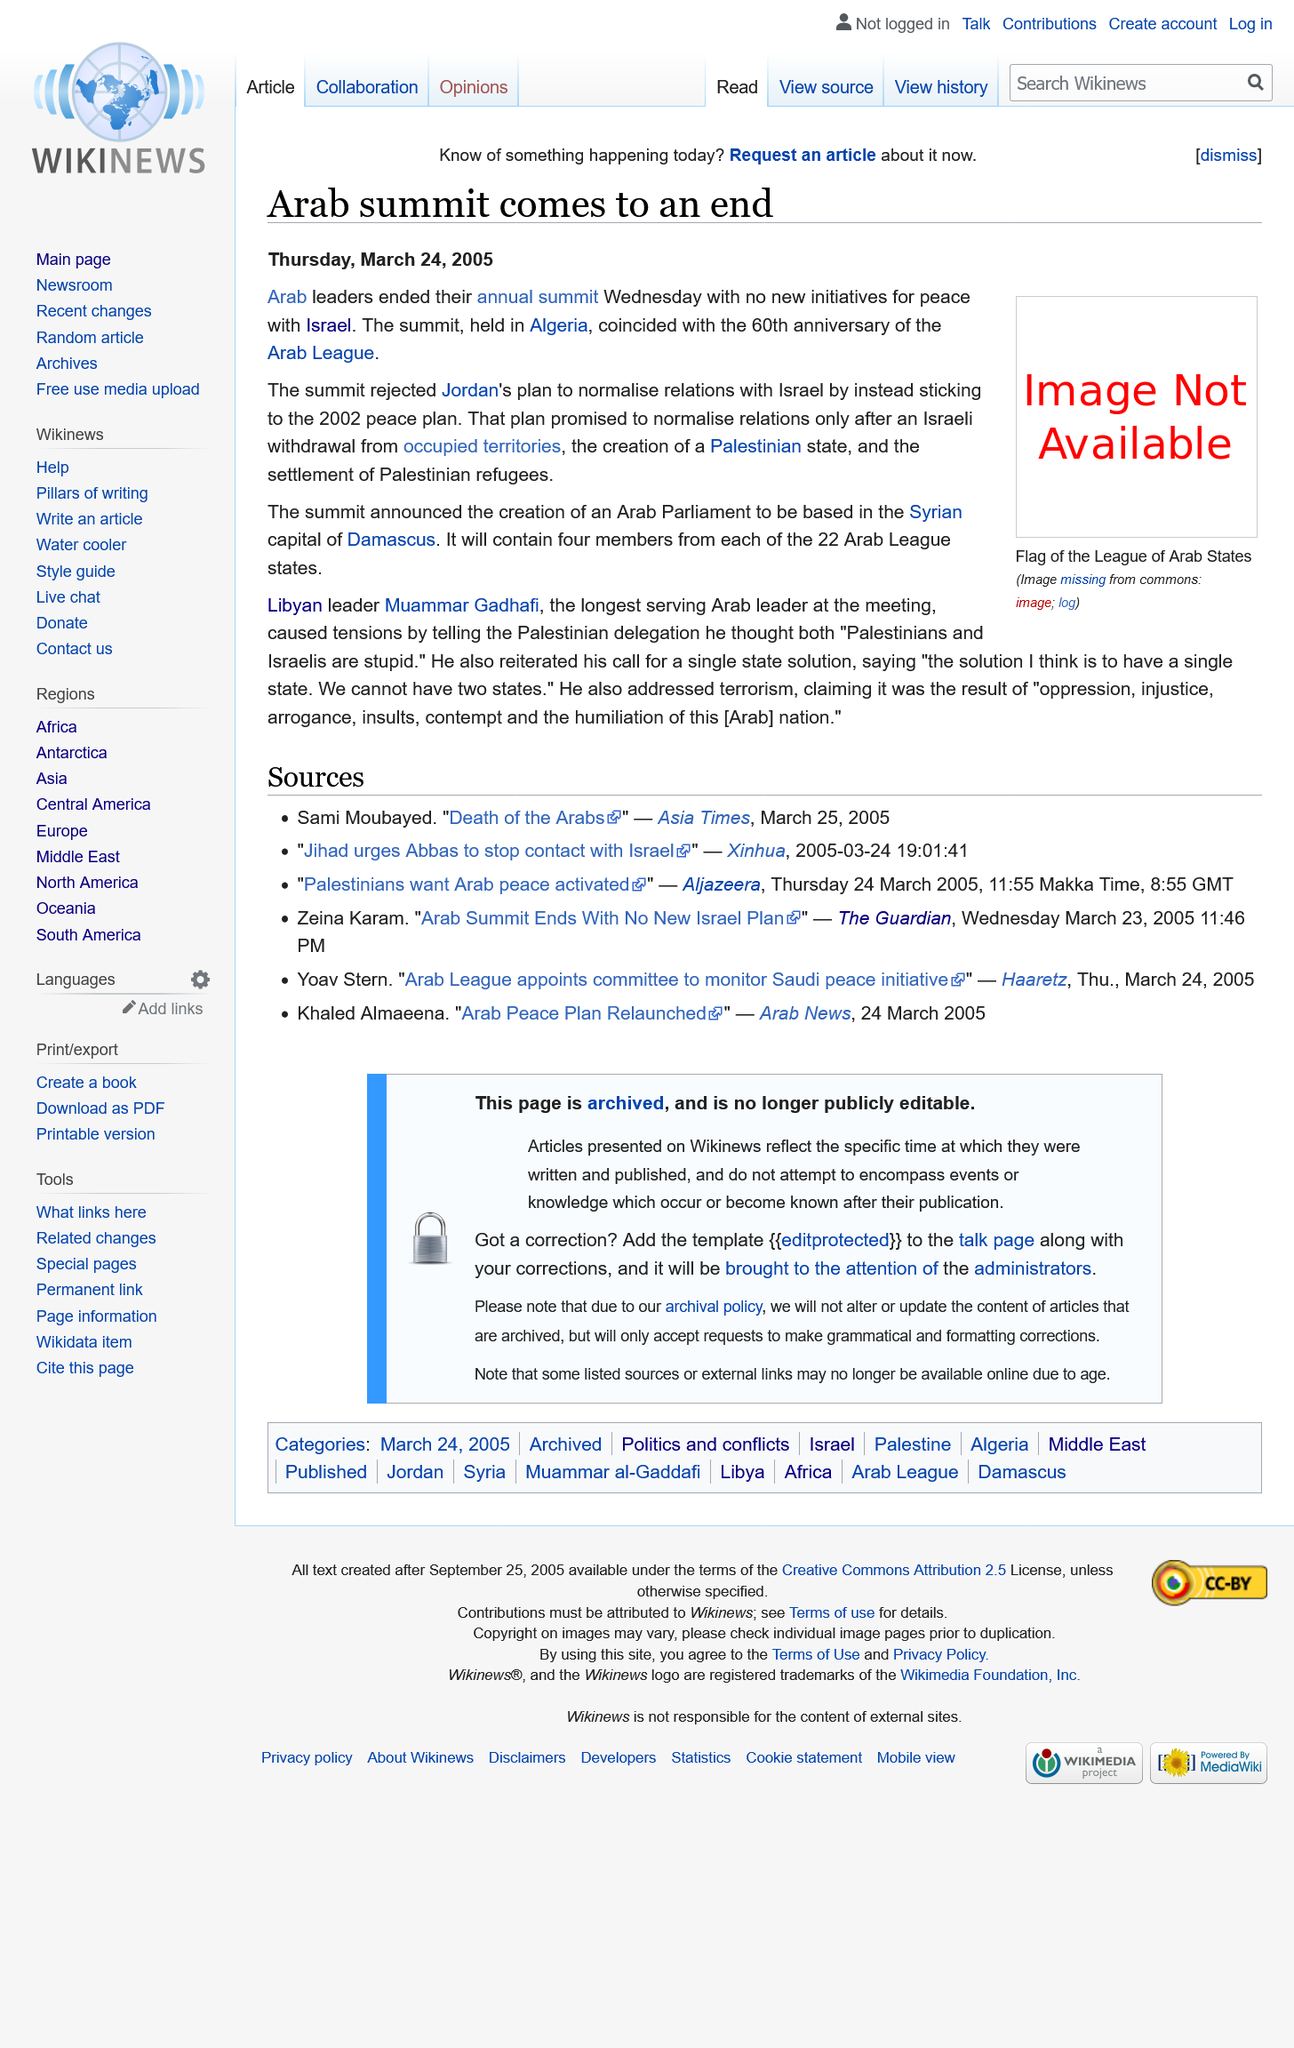Mention a couple of crucial points in this snapshot. The article was published on March 24th, 2005. The creation of the Arab League was declared at the summit. The summit was held in Algeria. 